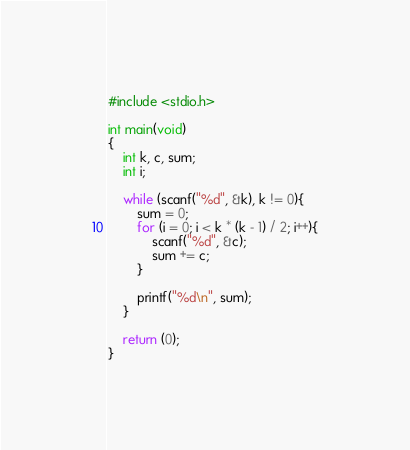Convert code to text. <code><loc_0><loc_0><loc_500><loc_500><_C_>#include <stdio.h>

int main(void)
{
	int k, c, sum;
	int i;
	
	while (scanf("%d", &k), k != 0){
		sum = 0;
		for (i = 0; i < k * (k - 1) / 2; i++){
			scanf("%d", &c);
			sum += c;
		}
		
		printf("%d\n", sum);
	}
	
	return (0);
}</code> 